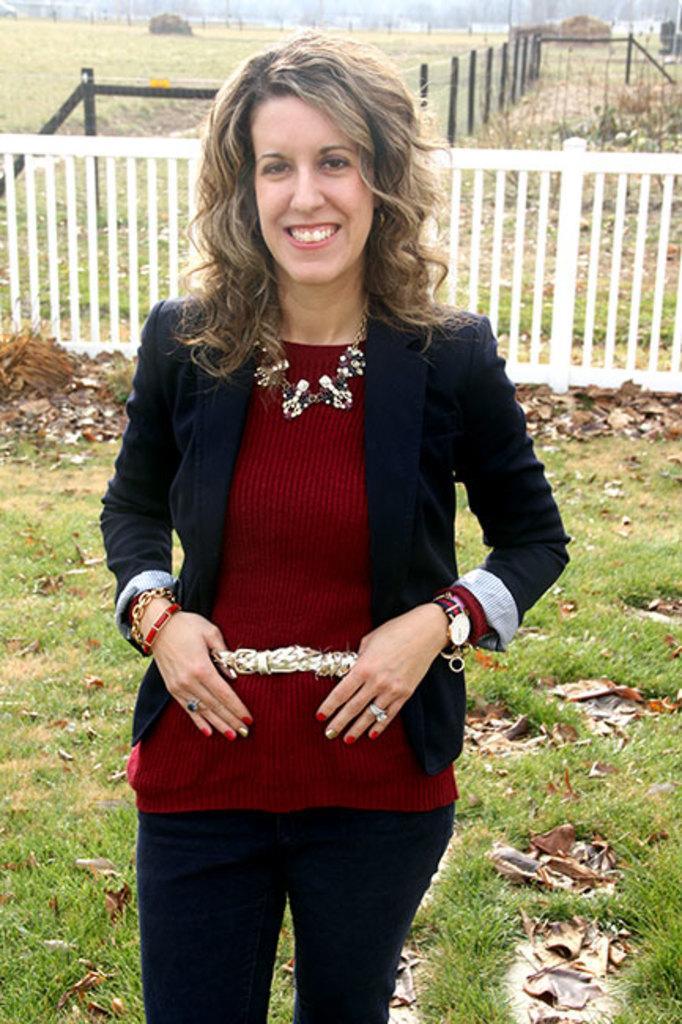In one or two sentences, can you explain what this image depicts? Here I can see a woman standing, smiling and giving pose for the picture. At the bottom, I can see the grass and dry leaves on the ground. In the background there is a fencing and few plants. 